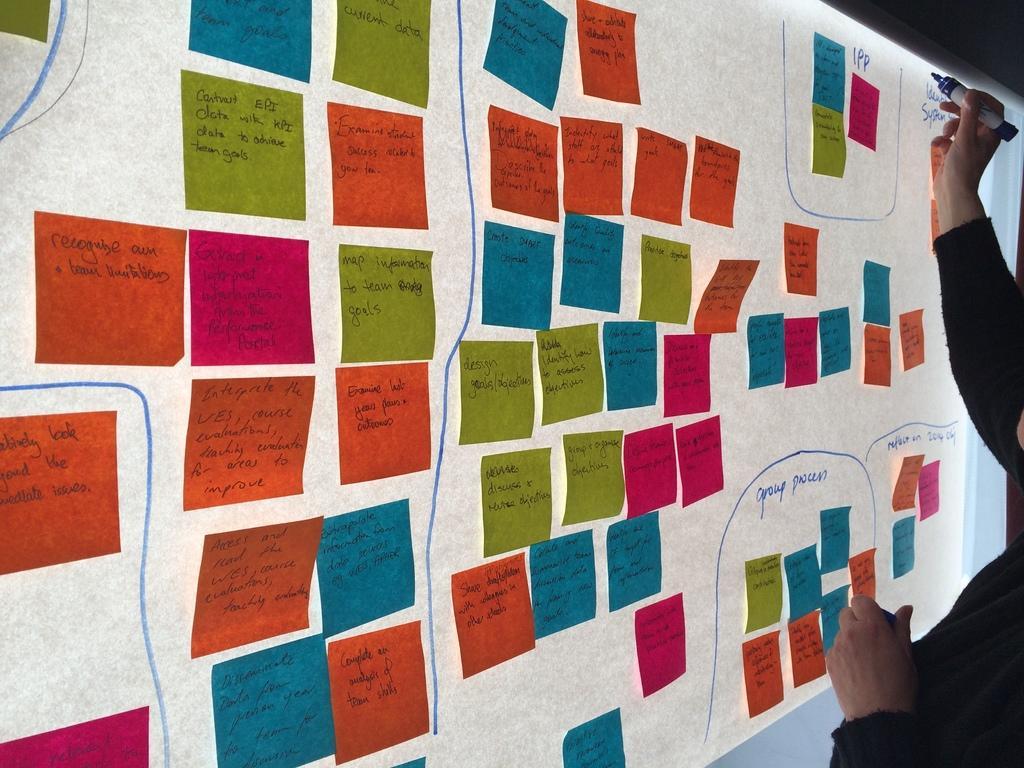In one or two sentences, can you explain what this image depicts? In this image we can see a screen on which some colored papers are pasted and some text was written on it. A person is making something on the screen. 